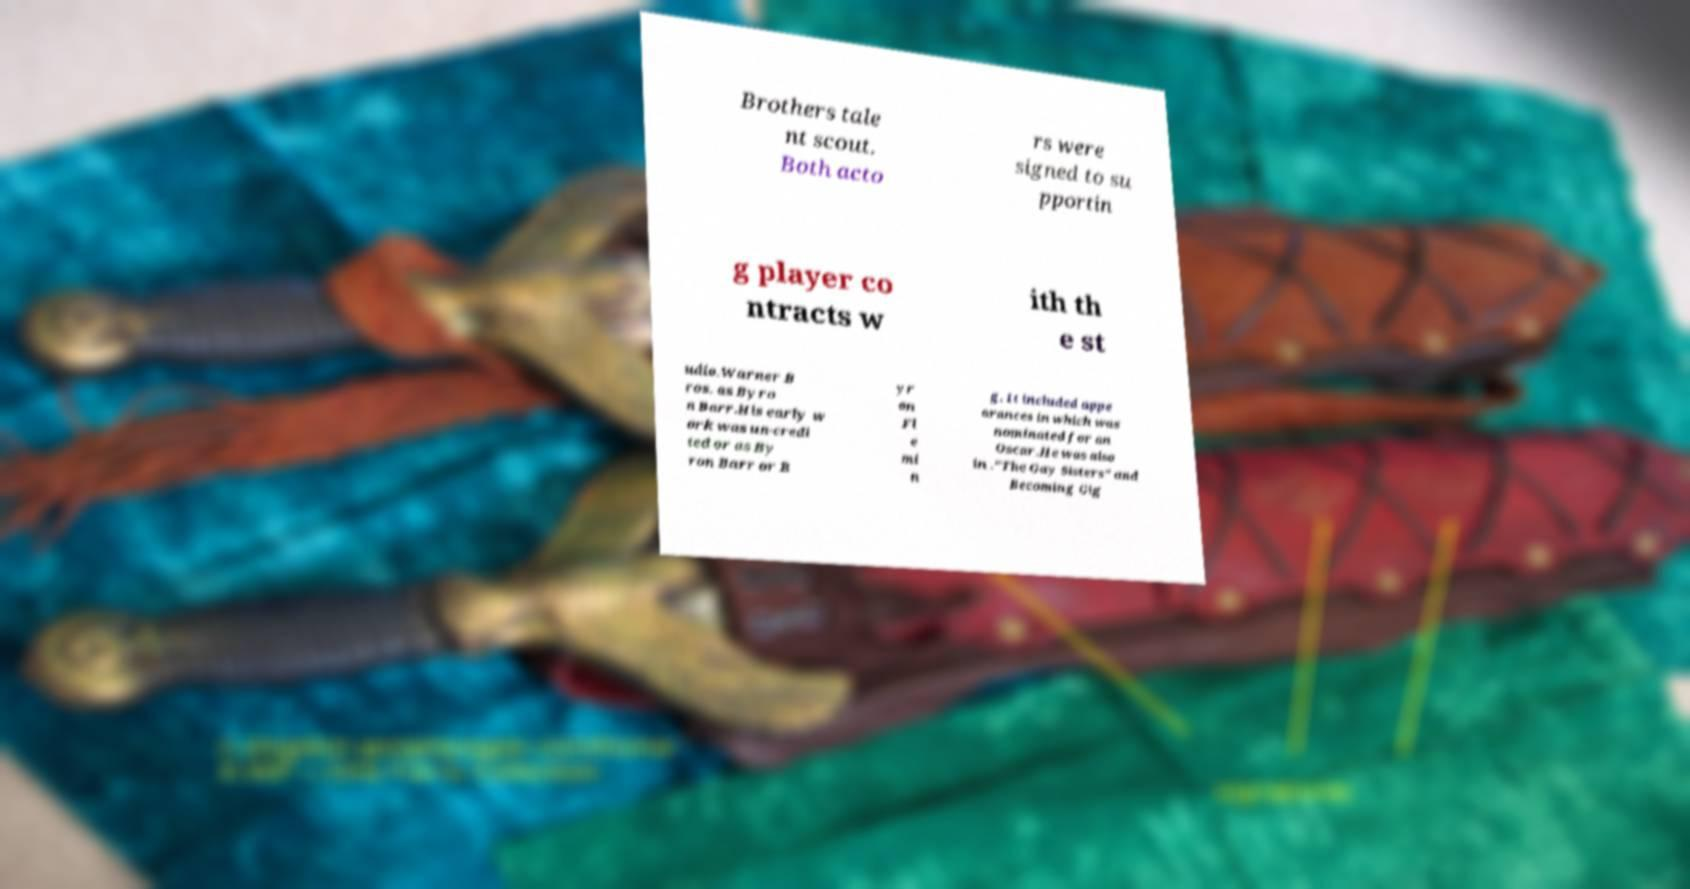Can you read and provide the text displayed in the image?This photo seems to have some interesting text. Can you extract and type it out for me? Brothers tale nt scout. Both acto rs were signed to su pportin g player co ntracts w ith th e st udio.Warner B ros. as Byro n Barr.His early w ork was un-credi ted or as By ron Barr or B yr on Fl e mi n g. It included appe arances in which was nominated for an Oscar.He was also in ."The Gay Sisters" and Becoming Gig 